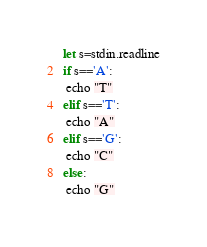<code> <loc_0><loc_0><loc_500><loc_500><_Nim_>let s=stdin.readline
if s=='A':
 echo "T"
elif s=='T':
 echo "A"
elif s=='G':
 echo "C"
else:
 echo "G"</code> 